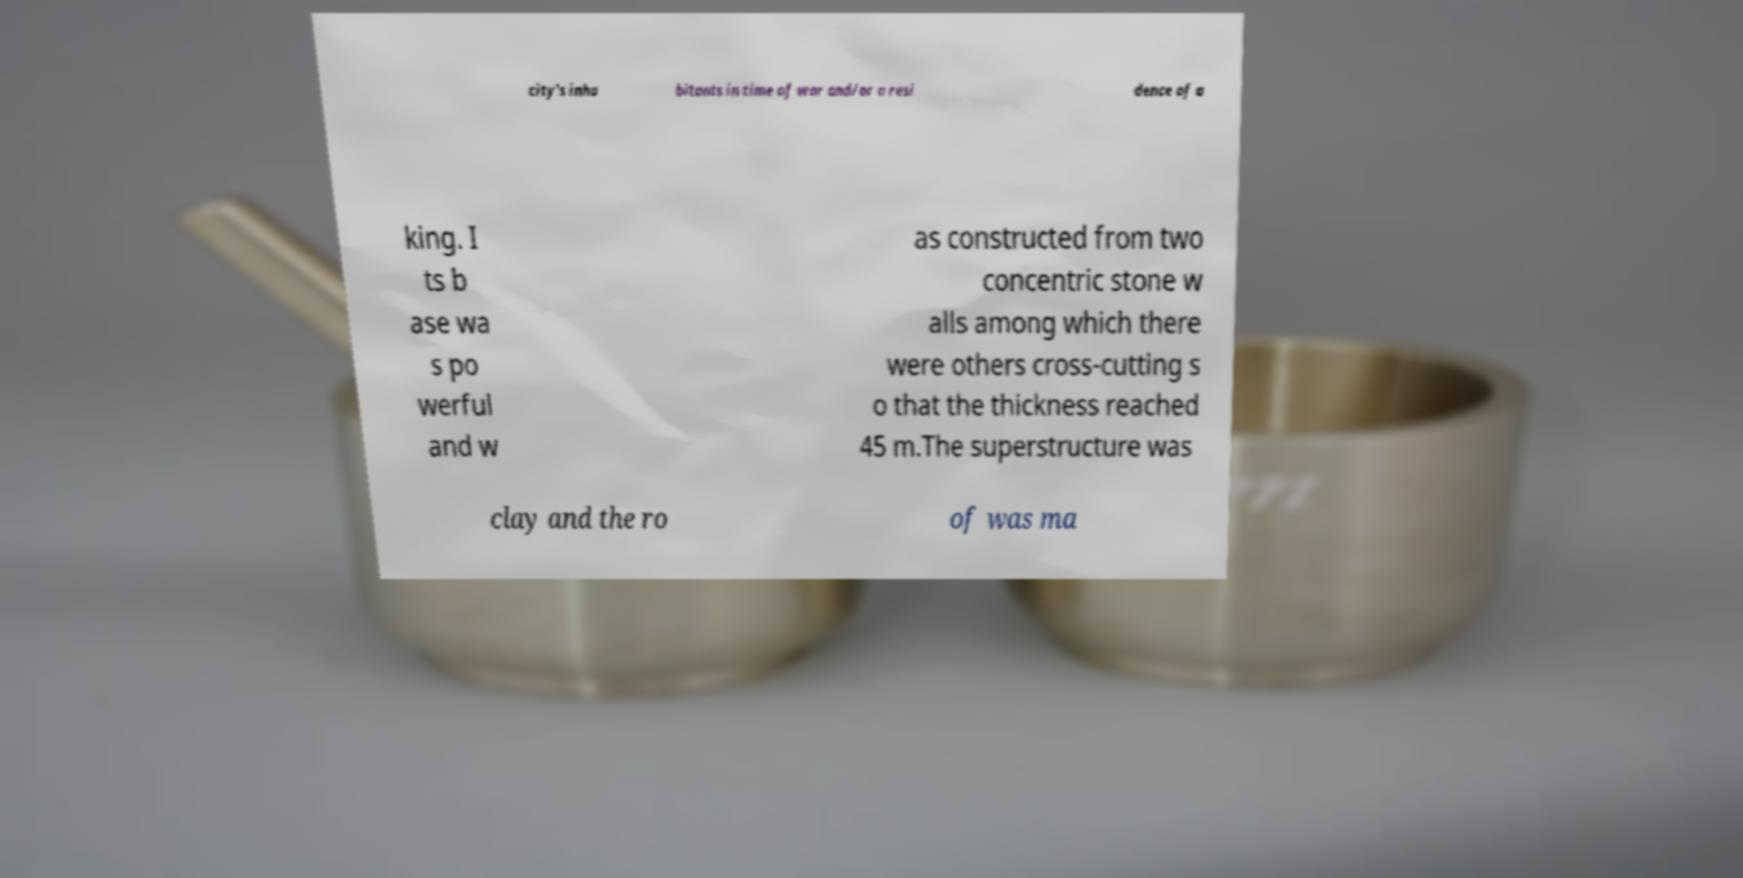Can you read and provide the text displayed in the image?This photo seems to have some interesting text. Can you extract and type it out for me? city's inha bitants in time of war and/or a resi dence of a king. I ts b ase wa s po werful and w as constructed from two concentric stone w alls among which there were others cross-cutting s o that the thickness reached 45 m.The superstructure was clay and the ro of was ma 